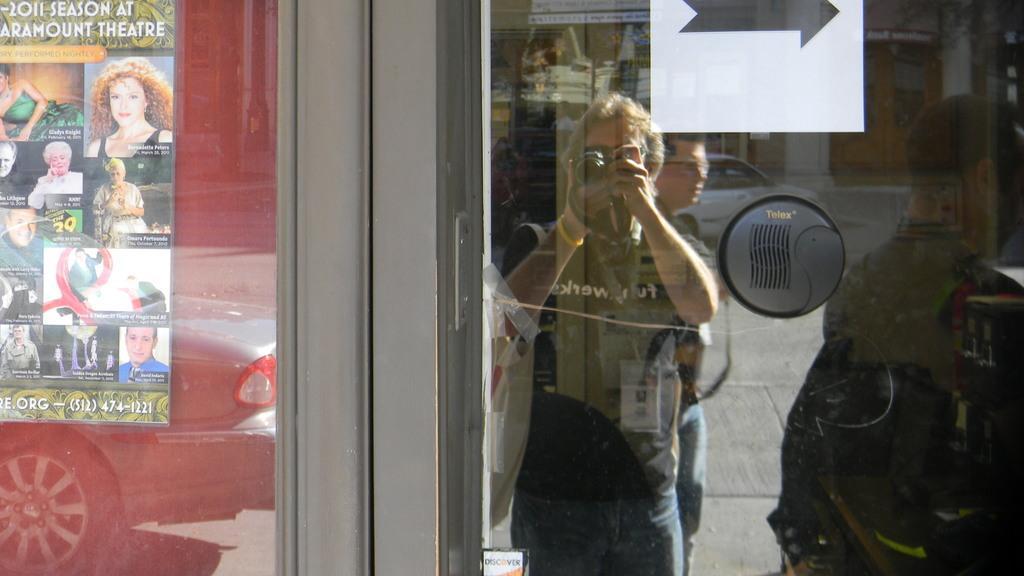Can you describe this image briefly? In the image we can see there are many people wearing clothes, this person is holding a camera in hand. We can see there is a vehicle on the road. This is a poster and this is a road. 